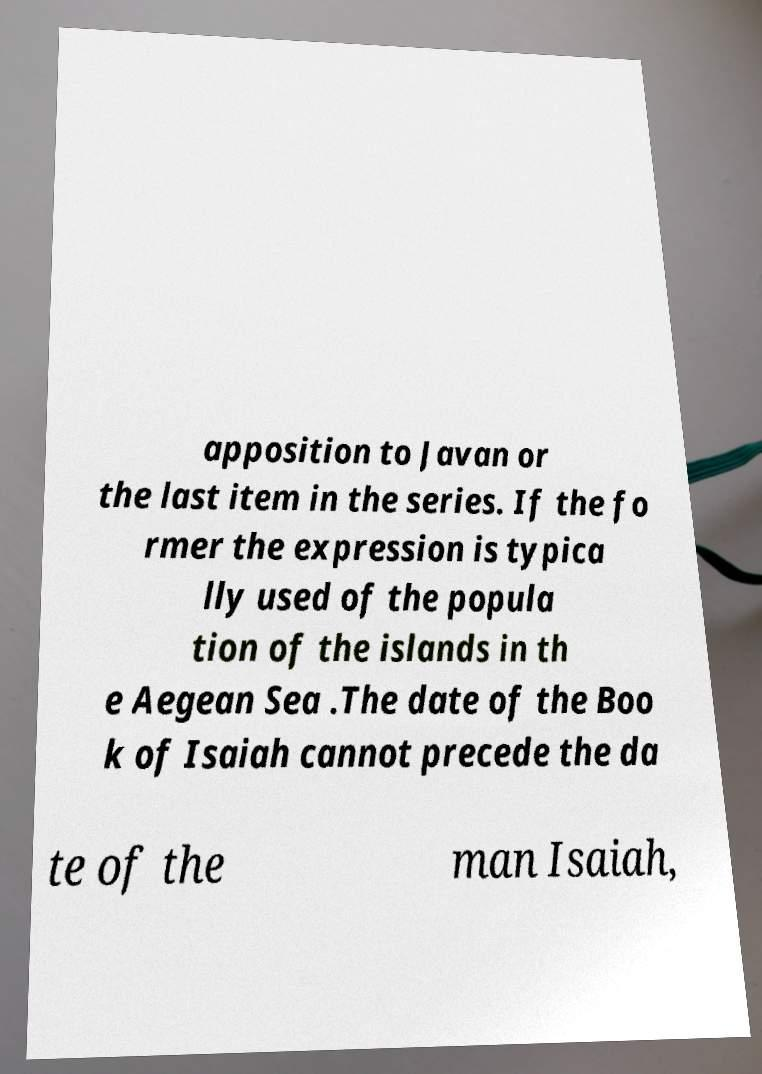What messages or text are displayed in this image? I need them in a readable, typed format. apposition to Javan or the last item in the series. If the fo rmer the expression is typica lly used of the popula tion of the islands in th e Aegean Sea .The date of the Boo k of Isaiah cannot precede the da te of the man Isaiah, 